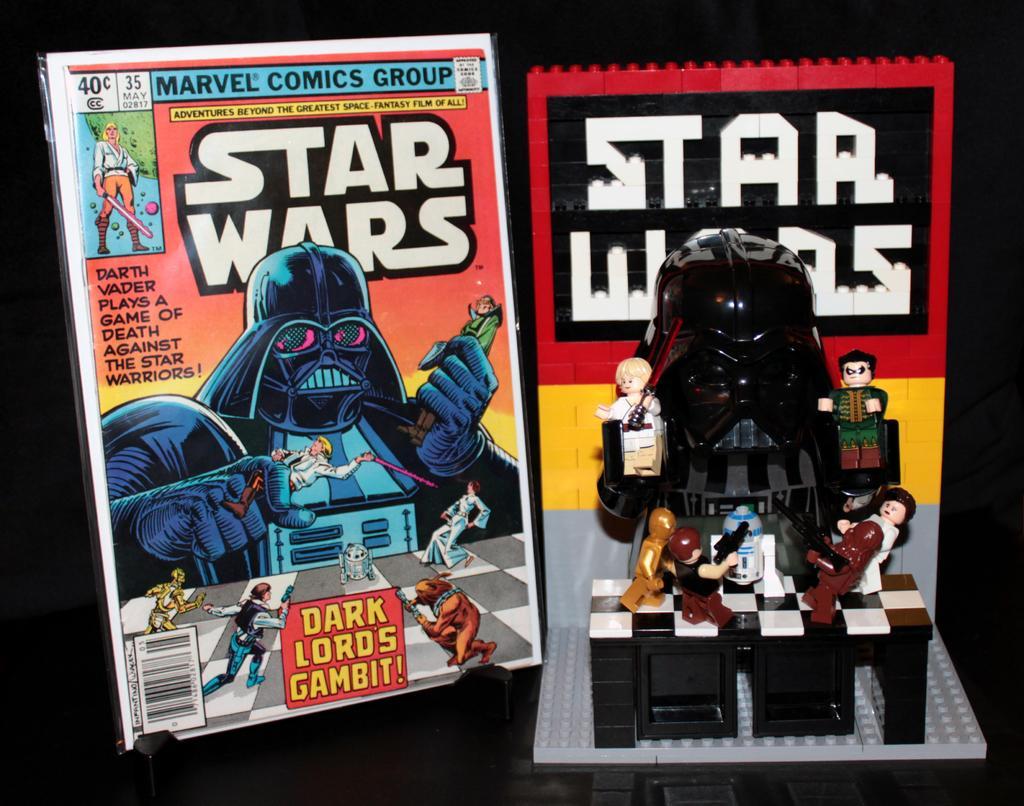Could you give a brief overview of what you see in this image? In the middle of the image there are some toys and books. 